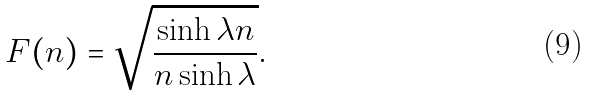<formula> <loc_0><loc_0><loc_500><loc_500>F ( n ) = \sqrt { \frac { \sinh \lambda n } { n \sinh \lambda } } .</formula> 